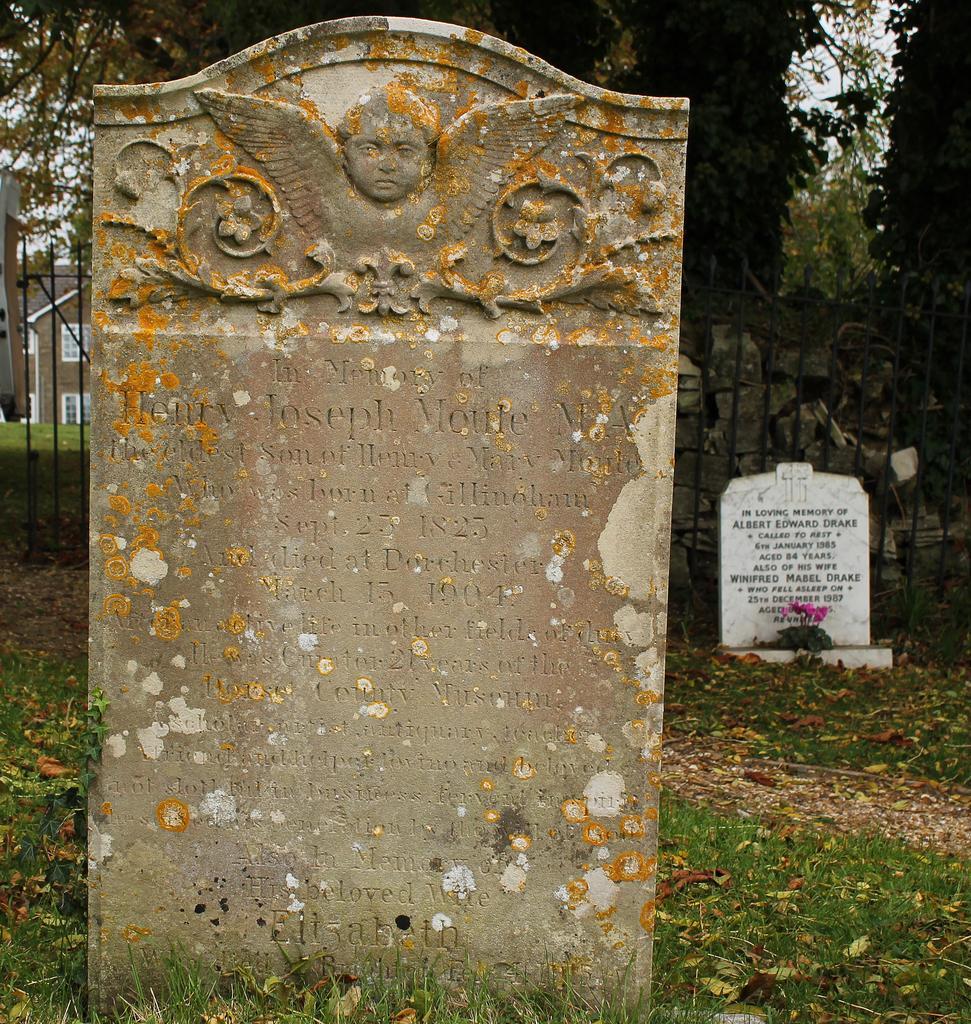Could you give a brief overview of what you see in this image? In this image, there are graveyard stones on the ground. There are grills on the left and on the right side of the image. There are trees in the top right of the image. 